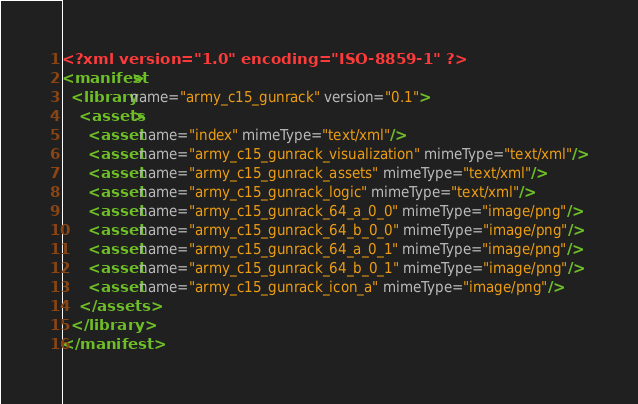Convert code to text. <code><loc_0><loc_0><loc_500><loc_500><_XML_><?xml version="1.0" encoding="ISO-8859-1" ?><manifest>
  <library name="army_c15_gunrack" version="0.1">
    <assets>
      <asset name="index" mimeType="text/xml"/>
      <asset name="army_c15_gunrack_visualization" mimeType="text/xml"/>
      <asset name="army_c15_gunrack_assets" mimeType="text/xml"/>
      <asset name="army_c15_gunrack_logic" mimeType="text/xml"/>
      <asset name="army_c15_gunrack_64_a_0_0" mimeType="image/png"/>
      <asset name="army_c15_gunrack_64_b_0_0" mimeType="image/png"/>
      <asset name="army_c15_gunrack_64_a_0_1" mimeType="image/png"/>
      <asset name="army_c15_gunrack_64_b_0_1" mimeType="image/png"/>
      <asset name="army_c15_gunrack_icon_a" mimeType="image/png"/>
    </assets>
  </library>
</manifest></code> 